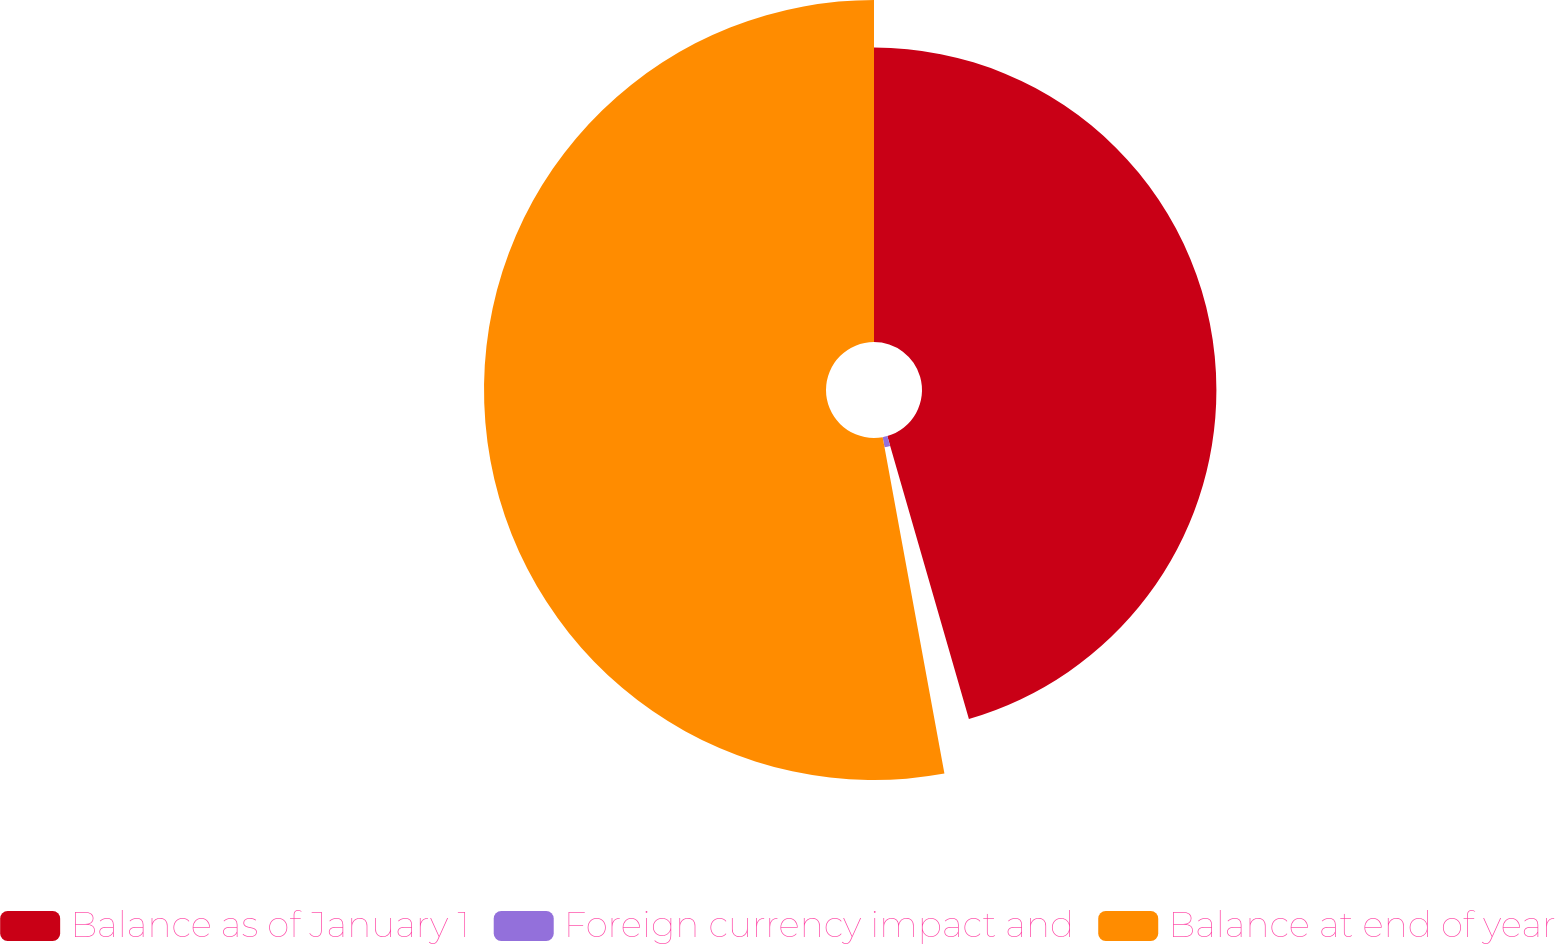Convert chart to OTSL. <chart><loc_0><loc_0><loc_500><loc_500><pie_chart><fcel>Balance as of January 1<fcel>Foreign currency impact and<fcel>Balance at end of year<nl><fcel>45.53%<fcel>1.58%<fcel>52.89%<nl></chart> 